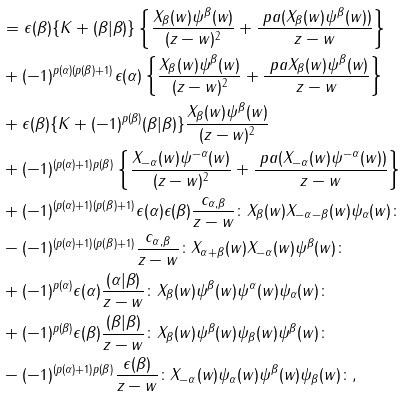<formula> <loc_0><loc_0><loc_500><loc_500>& = \epsilon ( \beta ) \{ K + ( \beta | \beta ) \} \left \{ \frac { X _ { \beta } ( w ) \psi ^ { \beta } ( w ) } { ( z - w ) ^ { 2 } } + \frac { \ p a ( X _ { \beta } ( w ) \psi ^ { \beta } ( w ) ) } { z - w } \right \} \\ & + ( - 1 ) ^ { p ( \alpha ) ( p ( \beta ) + 1 ) } \epsilon ( \alpha ) \left \{ \frac { X _ { \beta } ( w ) \psi ^ { \beta } ( w ) } { ( z - w ) ^ { 2 } } + \frac { \ p a X _ { \beta } ( w ) \psi ^ { \beta } ( w ) } { z - w } \right \} \\ & + \epsilon ( \beta ) \{ K + ( - 1 ) ^ { p ( \beta ) } ( \beta | \beta ) \} \frac { X _ { \beta } ( w ) \psi ^ { \beta } ( w ) } { ( z - w ) ^ { 2 } } \\ & + ( - 1 ) ^ { ( p ( \alpha ) + 1 ) p ( \beta ) } \left \{ \frac { X _ { - \alpha } ( w ) \psi ^ { - \alpha } ( w ) } { ( z - w ) ^ { 2 } } + \frac { \ p a ( X _ { - \alpha } ( w ) \psi ^ { - \alpha } ( w ) ) } { z - w } \right \} \\ & + ( - 1 ) ^ { ( p ( \alpha ) + 1 ) ( p ( \beta ) + 1 ) } \epsilon ( \alpha ) \epsilon ( \beta ) \frac { c _ { \alpha , \beta } } { z - w } \colon X _ { \beta } ( w ) X _ { - \alpha - \beta } ( w ) \psi _ { \alpha } ( w ) \colon \\ & - ( - 1 ) ^ { ( p ( \alpha ) + 1 ) ( p ( \beta ) + 1 ) } \frac { c _ { \alpha , \beta } } { z - w } \colon X _ { \alpha + \beta } ( w ) X _ { - \alpha } ( w ) \psi ^ { \beta } ( w ) \colon \\ & + ( - 1 ) ^ { p ( \alpha ) } \epsilon ( \alpha ) \frac { ( \alpha | \beta ) } { z - w } \colon X _ { \beta } ( w ) \psi ^ { \beta } ( w ) \psi ^ { \alpha } ( w ) \psi _ { \alpha } ( w ) \colon \\ & + ( - 1 ) ^ { p ( \beta ) } \epsilon ( \beta ) \frac { ( \beta | \beta ) } { z - w } \colon X _ { \beta } ( w ) \psi ^ { \beta } ( w ) \psi _ { \beta } ( w ) \psi ^ { \beta } ( w ) \colon \\ & - ( - 1 ) ^ { ( p ( \alpha ) + 1 ) p ( \beta ) } \frac { \epsilon ( \beta ) } { z - w } \colon X _ { - \alpha } ( w ) \psi _ { \alpha } ( w ) \psi ^ { \beta } ( w ) \psi _ { \beta } ( w ) \colon ,</formula> 